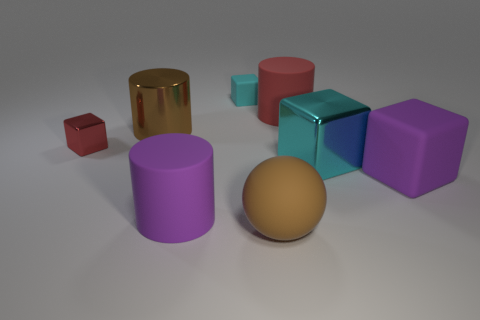Subtract all brown balls. How many cyan cubes are left? 2 Subtract 1 cylinders. How many cylinders are left? 2 Add 2 small cyan rubber cubes. How many objects exist? 10 Subtract all green cubes. Subtract all brown cylinders. How many cubes are left? 4 Subtract all spheres. How many objects are left? 7 Subtract all large yellow rubber spheres. Subtract all small red things. How many objects are left? 7 Add 6 big brown metallic cylinders. How many big brown metallic cylinders are left? 7 Add 5 large purple things. How many large purple things exist? 7 Subtract 1 brown cylinders. How many objects are left? 7 